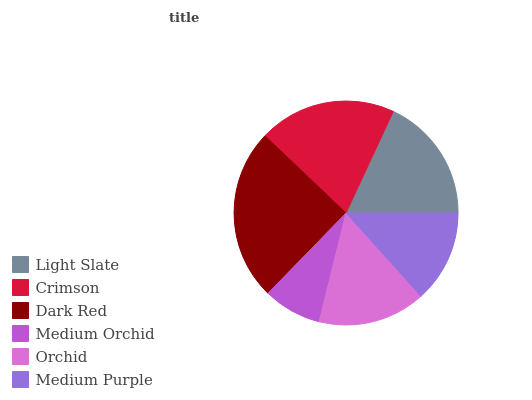Is Medium Orchid the minimum?
Answer yes or no. Yes. Is Dark Red the maximum?
Answer yes or no. Yes. Is Crimson the minimum?
Answer yes or no. No. Is Crimson the maximum?
Answer yes or no. No. Is Crimson greater than Light Slate?
Answer yes or no. Yes. Is Light Slate less than Crimson?
Answer yes or no. Yes. Is Light Slate greater than Crimson?
Answer yes or no. No. Is Crimson less than Light Slate?
Answer yes or no. No. Is Light Slate the high median?
Answer yes or no. Yes. Is Orchid the low median?
Answer yes or no. Yes. Is Crimson the high median?
Answer yes or no. No. Is Light Slate the low median?
Answer yes or no. No. 